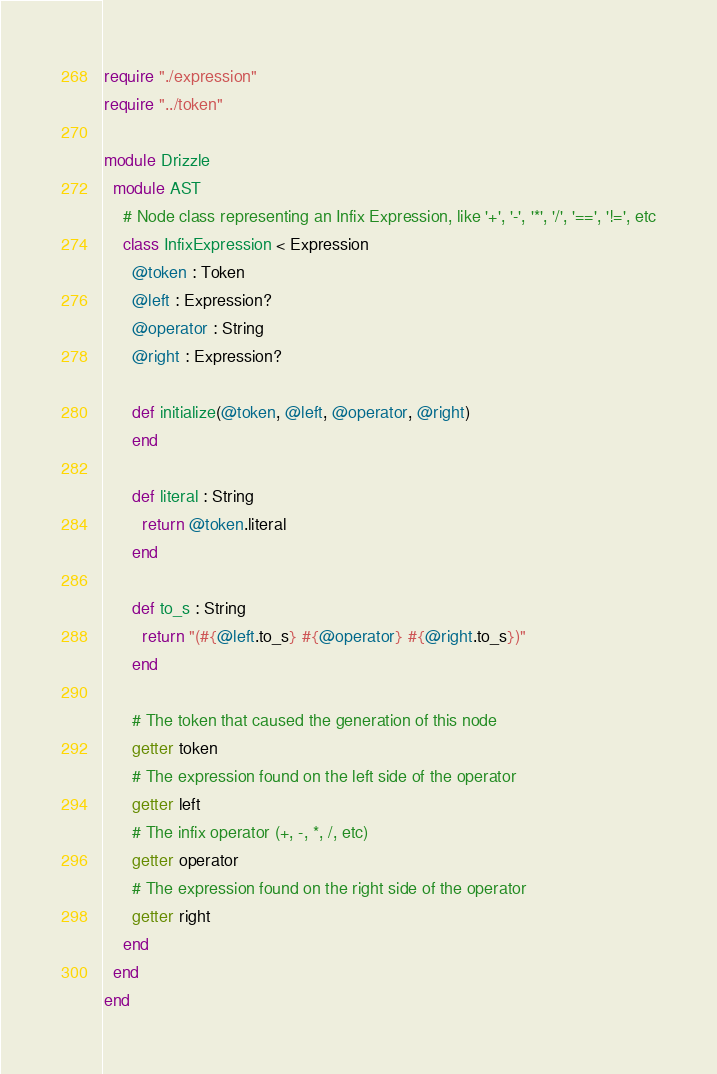<code> <loc_0><loc_0><loc_500><loc_500><_Crystal_>require "./expression"
require "../token"

module Drizzle
  module AST
    # Node class representing an Infix Expression, like '+', '-', '*', '/', '==', '!=', etc
    class InfixExpression < Expression
      @token : Token
      @left : Expression?
      @operator : String
      @right : Expression?

      def initialize(@token, @left, @operator, @right)
      end

      def literal : String
        return @token.literal
      end

      def to_s : String
        return "(#{@left.to_s} #{@operator} #{@right.to_s})"
      end

      # The token that caused the generation of this node
      getter token
      # The expression found on the left side of the operator
      getter left
      # The infix operator (+, -, *, /, etc)
      getter operator
      # The expression found on the right side of the operator
      getter right
    end
  end
end
</code> 